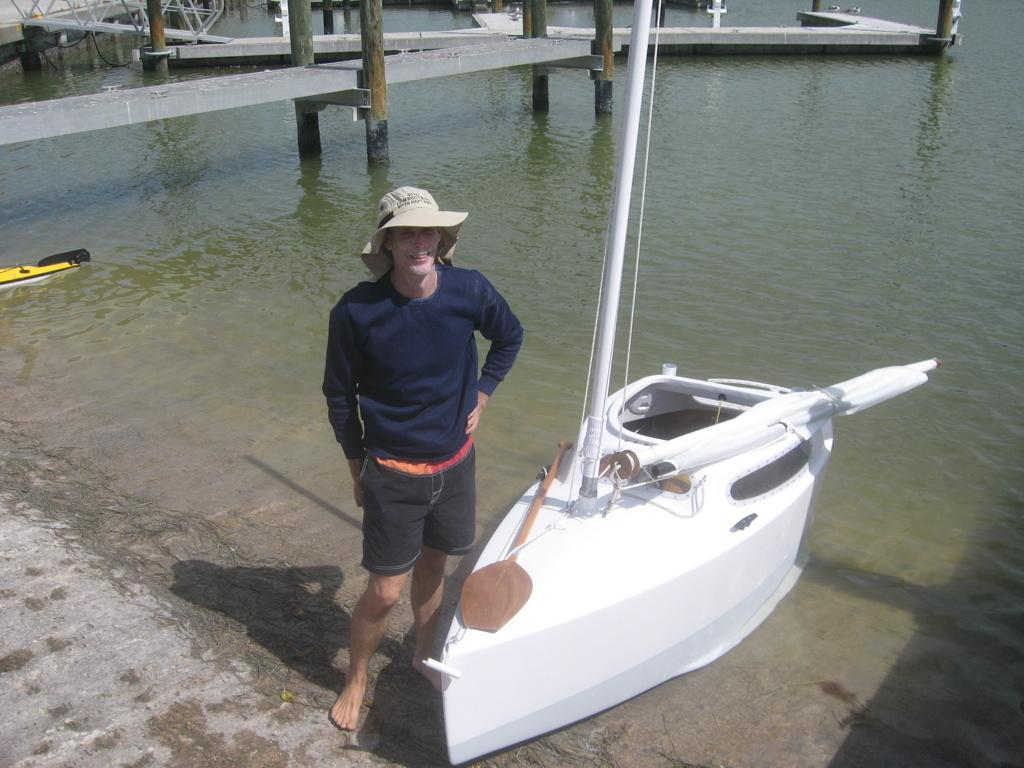What is the person in the image wearing on their head? The person in the image is wearing a cap. What type of boat can be seen in the image? There is a white color boat in the image. What can be seen in the background of the image? Water and poles are visible in the background of the image. How many snails are crawling on the boat in the image? There are no snails visible in the image; it features a person wearing a cap and a white color boat. What type of battle is taking place in the image? There is no battle depicted in the image; it shows a person wearing a cap and a boat on water. 